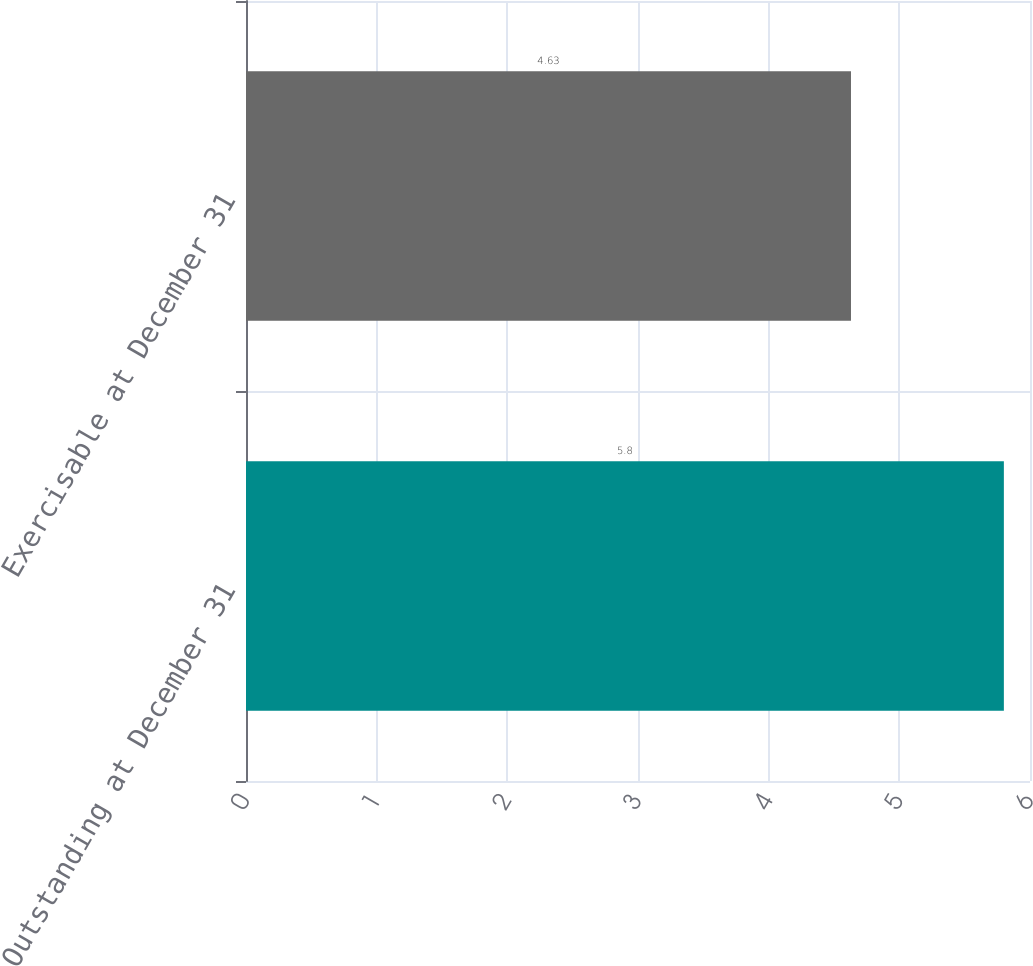Convert chart. <chart><loc_0><loc_0><loc_500><loc_500><bar_chart><fcel>Outstanding at December 31<fcel>Exercisable at December 31<nl><fcel>5.8<fcel>4.63<nl></chart> 